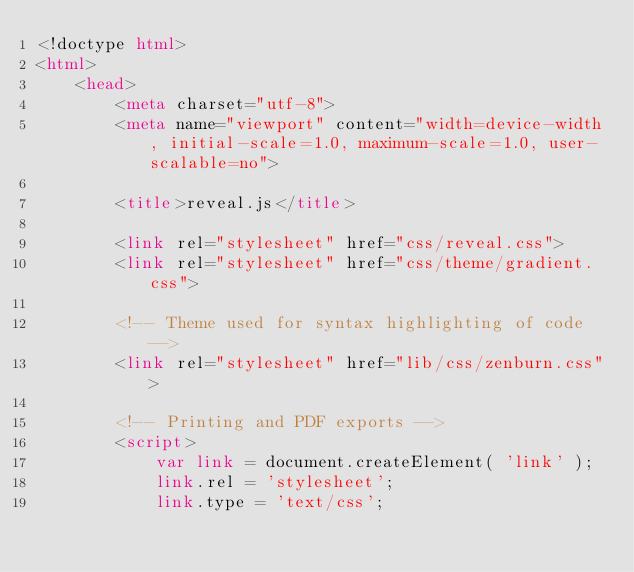<code> <loc_0><loc_0><loc_500><loc_500><_HTML_><!doctype html>
<html>
	<head>
		<meta charset="utf-8">
		<meta name="viewport" content="width=device-width, initial-scale=1.0, maximum-scale=1.0, user-scalable=no">

		<title>reveal.js</title>

		<link rel="stylesheet" href="css/reveal.css">
		<link rel="stylesheet" href="css/theme/gradient.css">

		<!-- Theme used for syntax highlighting of code -->
		<link rel="stylesheet" href="lib/css/zenburn.css">

		<!-- Printing and PDF exports -->
		<script>
			var link = document.createElement( 'link' );
			link.rel = 'stylesheet';
			link.type = 'text/css';</code> 